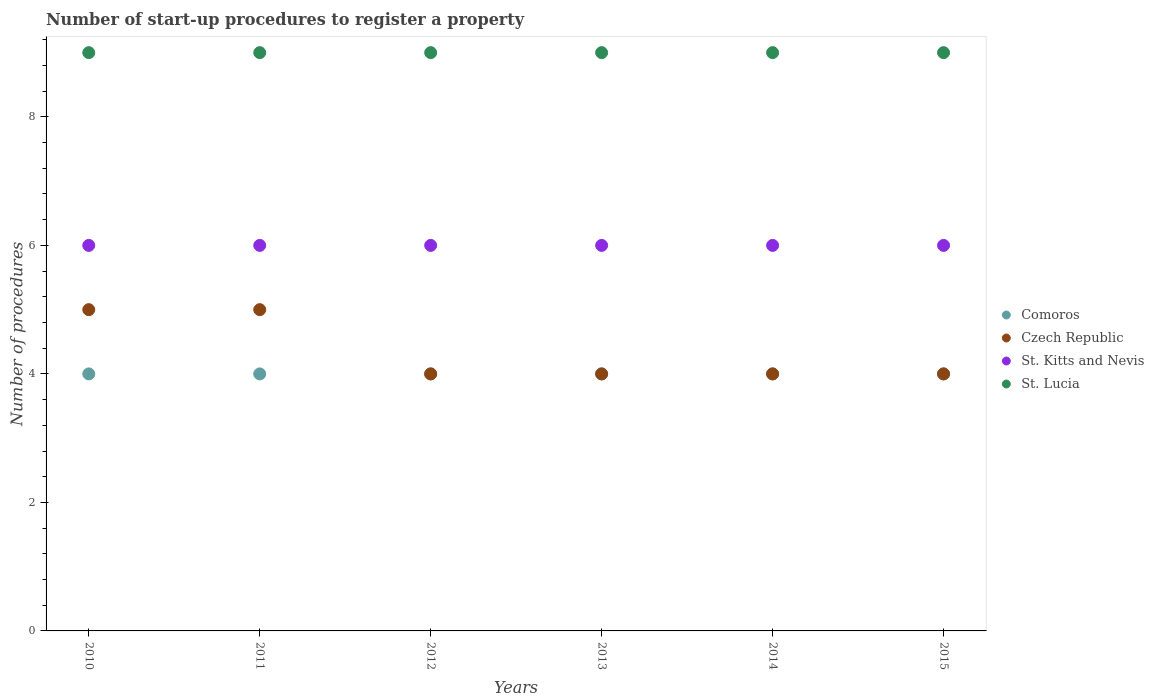Is the number of dotlines equal to the number of legend labels?
Your answer should be compact. Yes. Across all years, what is the minimum number of procedures required to register a property in Comoros?
Provide a succinct answer. 4. What is the total number of procedures required to register a property in St. Lucia in the graph?
Keep it short and to the point. 54. What is the difference between the number of procedures required to register a property in Czech Republic in 2011 and that in 2015?
Give a very brief answer. 1. What is the difference between the number of procedures required to register a property in St. Lucia in 2015 and the number of procedures required to register a property in Comoros in 2013?
Your response must be concise. 5. What is the average number of procedures required to register a property in Czech Republic per year?
Your answer should be compact. 4.33. In the year 2013, what is the difference between the number of procedures required to register a property in St. Kitts and Nevis and number of procedures required to register a property in Comoros?
Provide a short and direct response. 2. In how many years, is the number of procedures required to register a property in Czech Republic greater than 5.2?
Your answer should be compact. 0. Is the number of procedures required to register a property in Comoros in 2010 less than that in 2012?
Your answer should be very brief. No. Is the difference between the number of procedures required to register a property in St. Kitts and Nevis in 2011 and 2015 greater than the difference between the number of procedures required to register a property in Comoros in 2011 and 2015?
Your answer should be compact. No. What is the difference between the highest and the second highest number of procedures required to register a property in St. Kitts and Nevis?
Keep it short and to the point. 0. Is the sum of the number of procedures required to register a property in St. Kitts and Nevis in 2012 and 2015 greater than the maximum number of procedures required to register a property in Czech Republic across all years?
Your response must be concise. Yes. Does the number of procedures required to register a property in Czech Republic monotonically increase over the years?
Offer a very short reply. No. Is the number of procedures required to register a property in Czech Republic strictly greater than the number of procedures required to register a property in St. Lucia over the years?
Your answer should be very brief. No. How many dotlines are there?
Your response must be concise. 4. How many years are there in the graph?
Your answer should be compact. 6. How are the legend labels stacked?
Offer a very short reply. Vertical. What is the title of the graph?
Make the answer very short. Number of start-up procedures to register a property. Does "Serbia" appear as one of the legend labels in the graph?
Offer a very short reply. No. What is the label or title of the Y-axis?
Your answer should be very brief. Number of procedures. What is the Number of procedures in Czech Republic in 2010?
Offer a very short reply. 5. What is the Number of procedures in St. Kitts and Nevis in 2010?
Your answer should be compact. 6. What is the Number of procedures in Czech Republic in 2011?
Offer a terse response. 5. What is the Number of procedures of St. Kitts and Nevis in 2011?
Give a very brief answer. 6. What is the Number of procedures of Comoros in 2012?
Offer a terse response. 4. What is the Number of procedures of Czech Republic in 2012?
Ensure brevity in your answer.  4. What is the Number of procedures of Comoros in 2013?
Make the answer very short. 4. What is the Number of procedures of St. Lucia in 2013?
Offer a very short reply. 9. What is the Number of procedures of St. Lucia in 2014?
Offer a terse response. 9. What is the Number of procedures in Comoros in 2015?
Offer a terse response. 4. What is the Number of procedures of St. Lucia in 2015?
Ensure brevity in your answer.  9. Across all years, what is the maximum Number of procedures in Comoros?
Ensure brevity in your answer.  4. Across all years, what is the maximum Number of procedures of Czech Republic?
Your answer should be compact. 5. Across all years, what is the maximum Number of procedures of St. Lucia?
Provide a short and direct response. 9. Across all years, what is the minimum Number of procedures in Czech Republic?
Keep it short and to the point. 4. What is the total Number of procedures in Comoros in the graph?
Keep it short and to the point. 24. What is the total Number of procedures of Czech Republic in the graph?
Keep it short and to the point. 26. What is the difference between the Number of procedures in St. Kitts and Nevis in 2010 and that in 2011?
Offer a very short reply. 0. What is the difference between the Number of procedures of St. Lucia in 2010 and that in 2011?
Provide a succinct answer. 0. What is the difference between the Number of procedures in Comoros in 2010 and that in 2012?
Provide a succinct answer. 0. What is the difference between the Number of procedures of Czech Republic in 2010 and that in 2012?
Provide a short and direct response. 1. What is the difference between the Number of procedures in St. Kitts and Nevis in 2010 and that in 2012?
Ensure brevity in your answer.  0. What is the difference between the Number of procedures of Comoros in 2010 and that in 2014?
Provide a succinct answer. 0. What is the difference between the Number of procedures in Czech Republic in 2010 and that in 2014?
Your answer should be compact. 1. What is the difference between the Number of procedures of St. Lucia in 2010 and that in 2014?
Provide a succinct answer. 0. What is the difference between the Number of procedures in Comoros in 2011 and that in 2013?
Provide a succinct answer. 0. What is the difference between the Number of procedures in Czech Republic in 2011 and that in 2013?
Your answer should be compact. 1. What is the difference between the Number of procedures in St. Kitts and Nevis in 2011 and that in 2014?
Offer a terse response. 0. What is the difference between the Number of procedures of St. Lucia in 2011 and that in 2014?
Ensure brevity in your answer.  0. What is the difference between the Number of procedures in Comoros in 2011 and that in 2015?
Ensure brevity in your answer.  0. What is the difference between the Number of procedures of Czech Republic in 2011 and that in 2015?
Offer a very short reply. 1. What is the difference between the Number of procedures in Comoros in 2012 and that in 2013?
Give a very brief answer. 0. What is the difference between the Number of procedures in Czech Republic in 2012 and that in 2013?
Provide a short and direct response. 0. What is the difference between the Number of procedures in Comoros in 2012 and that in 2014?
Your answer should be compact. 0. What is the difference between the Number of procedures of St. Kitts and Nevis in 2012 and that in 2014?
Your answer should be very brief. 0. What is the difference between the Number of procedures in St. Lucia in 2012 and that in 2014?
Provide a succinct answer. 0. What is the difference between the Number of procedures of St. Kitts and Nevis in 2012 and that in 2015?
Give a very brief answer. 0. What is the difference between the Number of procedures in Comoros in 2013 and that in 2014?
Provide a succinct answer. 0. What is the difference between the Number of procedures of Czech Republic in 2013 and that in 2014?
Offer a terse response. 0. What is the difference between the Number of procedures in St. Kitts and Nevis in 2013 and that in 2014?
Keep it short and to the point. 0. What is the difference between the Number of procedures in St. Lucia in 2013 and that in 2014?
Your answer should be very brief. 0. What is the difference between the Number of procedures in Comoros in 2013 and that in 2015?
Offer a terse response. 0. What is the difference between the Number of procedures of St. Lucia in 2013 and that in 2015?
Your answer should be compact. 0. What is the difference between the Number of procedures in Comoros in 2014 and that in 2015?
Make the answer very short. 0. What is the difference between the Number of procedures of St. Kitts and Nevis in 2014 and that in 2015?
Your answer should be compact. 0. What is the difference between the Number of procedures of Comoros in 2010 and the Number of procedures of Czech Republic in 2011?
Give a very brief answer. -1. What is the difference between the Number of procedures in Comoros in 2010 and the Number of procedures in St. Lucia in 2011?
Keep it short and to the point. -5. What is the difference between the Number of procedures in Czech Republic in 2010 and the Number of procedures in St. Kitts and Nevis in 2011?
Provide a succinct answer. -1. What is the difference between the Number of procedures of Comoros in 2010 and the Number of procedures of St. Kitts and Nevis in 2012?
Make the answer very short. -2. What is the difference between the Number of procedures of Czech Republic in 2010 and the Number of procedures of St. Kitts and Nevis in 2012?
Keep it short and to the point. -1. What is the difference between the Number of procedures of St. Kitts and Nevis in 2010 and the Number of procedures of St. Lucia in 2012?
Your response must be concise. -3. What is the difference between the Number of procedures of Comoros in 2010 and the Number of procedures of Czech Republic in 2013?
Ensure brevity in your answer.  0. What is the difference between the Number of procedures in Czech Republic in 2010 and the Number of procedures in St. Lucia in 2013?
Your response must be concise. -4. What is the difference between the Number of procedures of Comoros in 2010 and the Number of procedures of St. Kitts and Nevis in 2014?
Your response must be concise. -2. What is the difference between the Number of procedures of Comoros in 2010 and the Number of procedures of Czech Republic in 2015?
Ensure brevity in your answer.  0. What is the difference between the Number of procedures of Czech Republic in 2010 and the Number of procedures of St. Kitts and Nevis in 2015?
Give a very brief answer. -1. What is the difference between the Number of procedures in St. Kitts and Nevis in 2010 and the Number of procedures in St. Lucia in 2015?
Offer a very short reply. -3. What is the difference between the Number of procedures of Comoros in 2011 and the Number of procedures of Czech Republic in 2012?
Offer a terse response. 0. What is the difference between the Number of procedures of Comoros in 2011 and the Number of procedures of St. Kitts and Nevis in 2012?
Offer a very short reply. -2. What is the difference between the Number of procedures of Czech Republic in 2011 and the Number of procedures of St. Kitts and Nevis in 2012?
Provide a short and direct response. -1. What is the difference between the Number of procedures of Comoros in 2011 and the Number of procedures of Czech Republic in 2013?
Your answer should be very brief. 0. What is the difference between the Number of procedures in Czech Republic in 2011 and the Number of procedures in St. Lucia in 2013?
Your answer should be compact. -4. What is the difference between the Number of procedures of St. Kitts and Nevis in 2011 and the Number of procedures of St. Lucia in 2013?
Your answer should be compact. -3. What is the difference between the Number of procedures in Czech Republic in 2011 and the Number of procedures in St. Lucia in 2014?
Offer a very short reply. -4. What is the difference between the Number of procedures in Comoros in 2011 and the Number of procedures in St. Kitts and Nevis in 2015?
Provide a short and direct response. -2. What is the difference between the Number of procedures of Comoros in 2011 and the Number of procedures of St. Lucia in 2015?
Ensure brevity in your answer.  -5. What is the difference between the Number of procedures in Comoros in 2012 and the Number of procedures in Czech Republic in 2013?
Ensure brevity in your answer.  0. What is the difference between the Number of procedures in Comoros in 2012 and the Number of procedures in St. Kitts and Nevis in 2013?
Offer a terse response. -2. What is the difference between the Number of procedures in Comoros in 2012 and the Number of procedures in St. Lucia in 2013?
Your answer should be very brief. -5. What is the difference between the Number of procedures of Czech Republic in 2012 and the Number of procedures of St. Kitts and Nevis in 2013?
Provide a succinct answer. -2. What is the difference between the Number of procedures in Czech Republic in 2012 and the Number of procedures in St. Lucia in 2013?
Your response must be concise. -5. What is the difference between the Number of procedures of Comoros in 2012 and the Number of procedures of St. Lucia in 2014?
Make the answer very short. -5. What is the difference between the Number of procedures in Czech Republic in 2012 and the Number of procedures in St. Kitts and Nevis in 2014?
Offer a very short reply. -2. What is the difference between the Number of procedures of Czech Republic in 2012 and the Number of procedures of St. Lucia in 2014?
Offer a very short reply. -5. What is the difference between the Number of procedures in St. Kitts and Nevis in 2012 and the Number of procedures in St. Lucia in 2014?
Offer a terse response. -3. What is the difference between the Number of procedures of Comoros in 2012 and the Number of procedures of Czech Republic in 2015?
Your answer should be very brief. 0. What is the difference between the Number of procedures in Comoros in 2012 and the Number of procedures in St. Lucia in 2015?
Ensure brevity in your answer.  -5. What is the difference between the Number of procedures of Czech Republic in 2012 and the Number of procedures of St. Kitts and Nevis in 2015?
Make the answer very short. -2. What is the difference between the Number of procedures of St. Kitts and Nevis in 2012 and the Number of procedures of St. Lucia in 2015?
Offer a very short reply. -3. What is the difference between the Number of procedures in Comoros in 2013 and the Number of procedures in Czech Republic in 2014?
Offer a very short reply. 0. What is the difference between the Number of procedures in Comoros in 2013 and the Number of procedures in St. Lucia in 2014?
Give a very brief answer. -5. What is the difference between the Number of procedures in Czech Republic in 2013 and the Number of procedures in St. Kitts and Nevis in 2014?
Ensure brevity in your answer.  -2. What is the difference between the Number of procedures of St. Kitts and Nevis in 2013 and the Number of procedures of St. Lucia in 2014?
Your answer should be very brief. -3. What is the difference between the Number of procedures in Comoros in 2013 and the Number of procedures in Czech Republic in 2015?
Provide a short and direct response. 0. What is the difference between the Number of procedures of Czech Republic in 2013 and the Number of procedures of St. Kitts and Nevis in 2015?
Your answer should be very brief. -2. What is the difference between the Number of procedures of Czech Republic in 2013 and the Number of procedures of St. Lucia in 2015?
Make the answer very short. -5. What is the difference between the Number of procedures in St. Kitts and Nevis in 2013 and the Number of procedures in St. Lucia in 2015?
Keep it short and to the point. -3. What is the difference between the Number of procedures in Comoros in 2014 and the Number of procedures in Czech Republic in 2015?
Ensure brevity in your answer.  0. What is the difference between the Number of procedures of Comoros in 2014 and the Number of procedures of St. Kitts and Nevis in 2015?
Provide a short and direct response. -2. What is the difference between the Number of procedures in Czech Republic in 2014 and the Number of procedures in St. Kitts and Nevis in 2015?
Your answer should be compact. -2. What is the difference between the Number of procedures in St. Kitts and Nevis in 2014 and the Number of procedures in St. Lucia in 2015?
Make the answer very short. -3. What is the average Number of procedures in Comoros per year?
Ensure brevity in your answer.  4. What is the average Number of procedures in Czech Republic per year?
Make the answer very short. 4.33. What is the average Number of procedures of St. Kitts and Nevis per year?
Your answer should be compact. 6. In the year 2010, what is the difference between the Number of procedures in Czech Republic and Number of procedures in St. Lucia?
Offer a very short reply. -4. In the year 2011, what is the difference between the Number of procedures in Comoros and Number of procedures in Czech Republic?
Your response must be concise. -1. In the year 2011, what is the difference between the Number of procedures of Comoros and Number of procedures of St. Kitts and Nevis?
Your response must be concise. -2. In the year 2012, what is the difference between the Number of procedures in Comoros and Number of procedures in St. Kitts and Nevis?
Keep it short and to the point. -2. In the year 2012, what is the difference between the Number of procedures of Comoros and Number of procedures of St. Lucia?
Your response must be concise. -5. In the year 2012, what is the difference between the Number of procedures of Czech Republic and Number of procedures of St. Kitts and Nevis?
Make the answer very short. -2. In the year 2013, what is the difference between the Number of procedures of Comoros and Number of procedures of Czech Republic?
Ensure brevity in your answer.  0. In the year 2013, what is the difference between the Number of procedures in Comoros and Number of procedures in St. Kitts and Nevis?
Offer a terse response. -2. In the year 2013, what is the difference between the Number of procedures of Comoros and Number of procedures of St. Lucia?
Your answer should be very brief. -5. In the year 2013, what is the difference between the Number of procedures of St. Kitts and Nevis and Number of procedures of St. Lucia?
Offer a terse response. -3. In the year 2014, what is the difference between the Number of procedures of Comoros and Number of procedures of Czech Republic?
Your answer should be compact. 0. In the year 2014, what is the difference between the Number of procedures of Comoros and Number of procedures of St. Kitts and Nevis?
Make the answer very short. -2. In the year 2014, what is the difference between the Number of procedures of Czech Republic and Number of procedures of St. Kitts and Nevis?
Your response must be concise. -2. In the year 2015, what is the difference between the Number of procedures in Comoros and Number of procedures in Czech Republic?
Keep it short and to the point. 0. In the year 2015, what is the difference between the Number of procedures of Comoros and Number of procedures of St. Kitts and Nevis?
Make the answer very short. -2. In the year 2015, what is the difference between the Number of procedures of Czech Republic and Number of procedures of St. Kitts and Nevis?
Offer a very short reply. -2. In the year 2015, what is the difference between the Number of procedures in Czech Republic and Number of procedures in St. Lucia?
Your answer should be compact. -5. In the year 2015, what is the difference between the Number of procedures of St. Kitts and Nevis and Number of procedures of St. Lucia?
Offer a very short reply. -3. What is the ratio of the Number of procedures in Czech Republic in 2010 to that in 2011?
Ensure brevity in your answer.  1. What is the ratio of the Number of procedures in St. Kitts and Nevis in 2010 to that in 2011?
Offer a terse response. 1. What is the ratio of the Number of procedures in St. Lucia in 2010 to that in 2011?
Make the answer very short. 1. What is the ratio of the Number of procedures of Czech Republic in 2010 to that in 2012?
Ensure brevity in your answer.  1.25. What is the ratio of the Number of procedures in St. Kitts and Nevis in 2010 to that in 2012?
Your answer should be very brief. 1. What is the ratio of the Number of procedures of St. Lucia in 2010 to that in 2012?
Give a very brief answer. 1. What is the ratio of the Number of procedures in Czech Republic in 2010 to that in 2013?
Offer a very short reply. 1.25. What is the ratio of the Number of procedures of St. Lucia in 2010 to that in 2013?
Give a very brief answer. 1. What is the ratio of the Number of procedures in Comoros in 2010 to that in 2014?
Offer a very short reply. 1. What is the ratio of the Number of procedures in St. Kitts and Nevis in 2010 to that in 2014?
Keep it short and to the point. 1. What is the ratio of the Number of procedures in Comoros in 2010 to that in 2015?
Your response must be concise. 1. What is the ratio of the Number of procedures of Czech Republic in 2010 to that in 2015?
Make the answer very short. 1.25. What is the ratio of the Number of procedures of St. Lucia in 2010 to that in 2015?
Your response must be concise. 1. What is the ratio of the Number of procedures in Comoros in 2011 to that in 2012?
Your answer should be compact. 1. What is the ratio of the Number of procedures in Comoros in 2011 to that in 2013?
Provide a short and direct response. 1. What is the ratio of the Number of procedures in St. Kitts and Nevis in 2011 to that in 2013?
Provide a succinct answer. 1. What is the ratio of the Number of procedures in Comoros in 2011 to that in 2014?
Make the answer very short. 1. What is the ratio of the Number of procedures in St. Kitts and Nevis in 2011 to that in 2014?
Your answer should be very brief. 1. What is the ratio of the Number of procedures in Comoros in 2011 to that in 2015?
Offer a very short reply. 1. What is the ratio of the Number of procedures in Czech Republic in 2011 to that in 2015?
Provide a succinct answer. 1.25. What is the ratio of the Number of procedures in Comoros in 2012 to that in 2013?
Your answer should be compact. 1. What is the ratio of the Number of procedures in Comoros in 2012 to that in 2014?
Ensure brevity in your answer.  1. What is the ratio of the Number of procedures in Czech Republic in 2012 to that in 2014?
Ensure brevity in your answer.  1. What is the ratio of the Number of procedures of St. Kitts and Nevis in 2012 to that in 2014?
Your answer should be very brief. 1. What is the ratio of the Number of procedures in St. Lucia in 2012 to that in 2014?
Ensure brevity in your answer.  1. What is the ratio of the Number of procedures of Comoros in 2012 to that in 2015?
Your answer should be compact. 1. What is the ratio of the Number of procedures in St. Kitts and Nevis in 2012 to that in 2015?
Keep it short and to the point. 1. What is the ratio of the Number of procedures in St. Lucia in 2012 to that in 2015?
Give a very brief answer. 1. What is the ratio of the Number of procedures in Comoros in 2013 to that in 2014?
Your answer should be very brief. 1. What is the ratio of the Number of procedures of St. Kitts and Nevis in 2013 to that in 2015?
Your answer should be very brief. 1. What is the ratio of the Number of procedures of Comoros in 2014 to that in 2015?
Keep it short and to the point. 1. What is the ratio of the Number of procedures of Czech Republic in 2014 to that in 2015?
Make the answer very short. 1. What is the ratio of the Number of procedures of St. Kitts and Nevis in 2014 to that in 2015?
Make the answer very short. 1. What is the ratio of the Number of procedures of St. Lucia in 2014 to that in 2015?
Provide a succinct answer. 1. What is the difference between the highest and the second highest Number of procedures of Comoros?
Give a very brief answer. 0. What is the difference between the highest and the second highest Number of procedures in Czech Republic?
Give a very brief answer. 0. What is the difference between the highest and the second highest Number of procedures in St. Kitts and Nevis?
Your answer should be very brief. 0. What is the difference between the highest and the lowest Number of procedures in Comoros?
Keep it short and to the point. 0. 